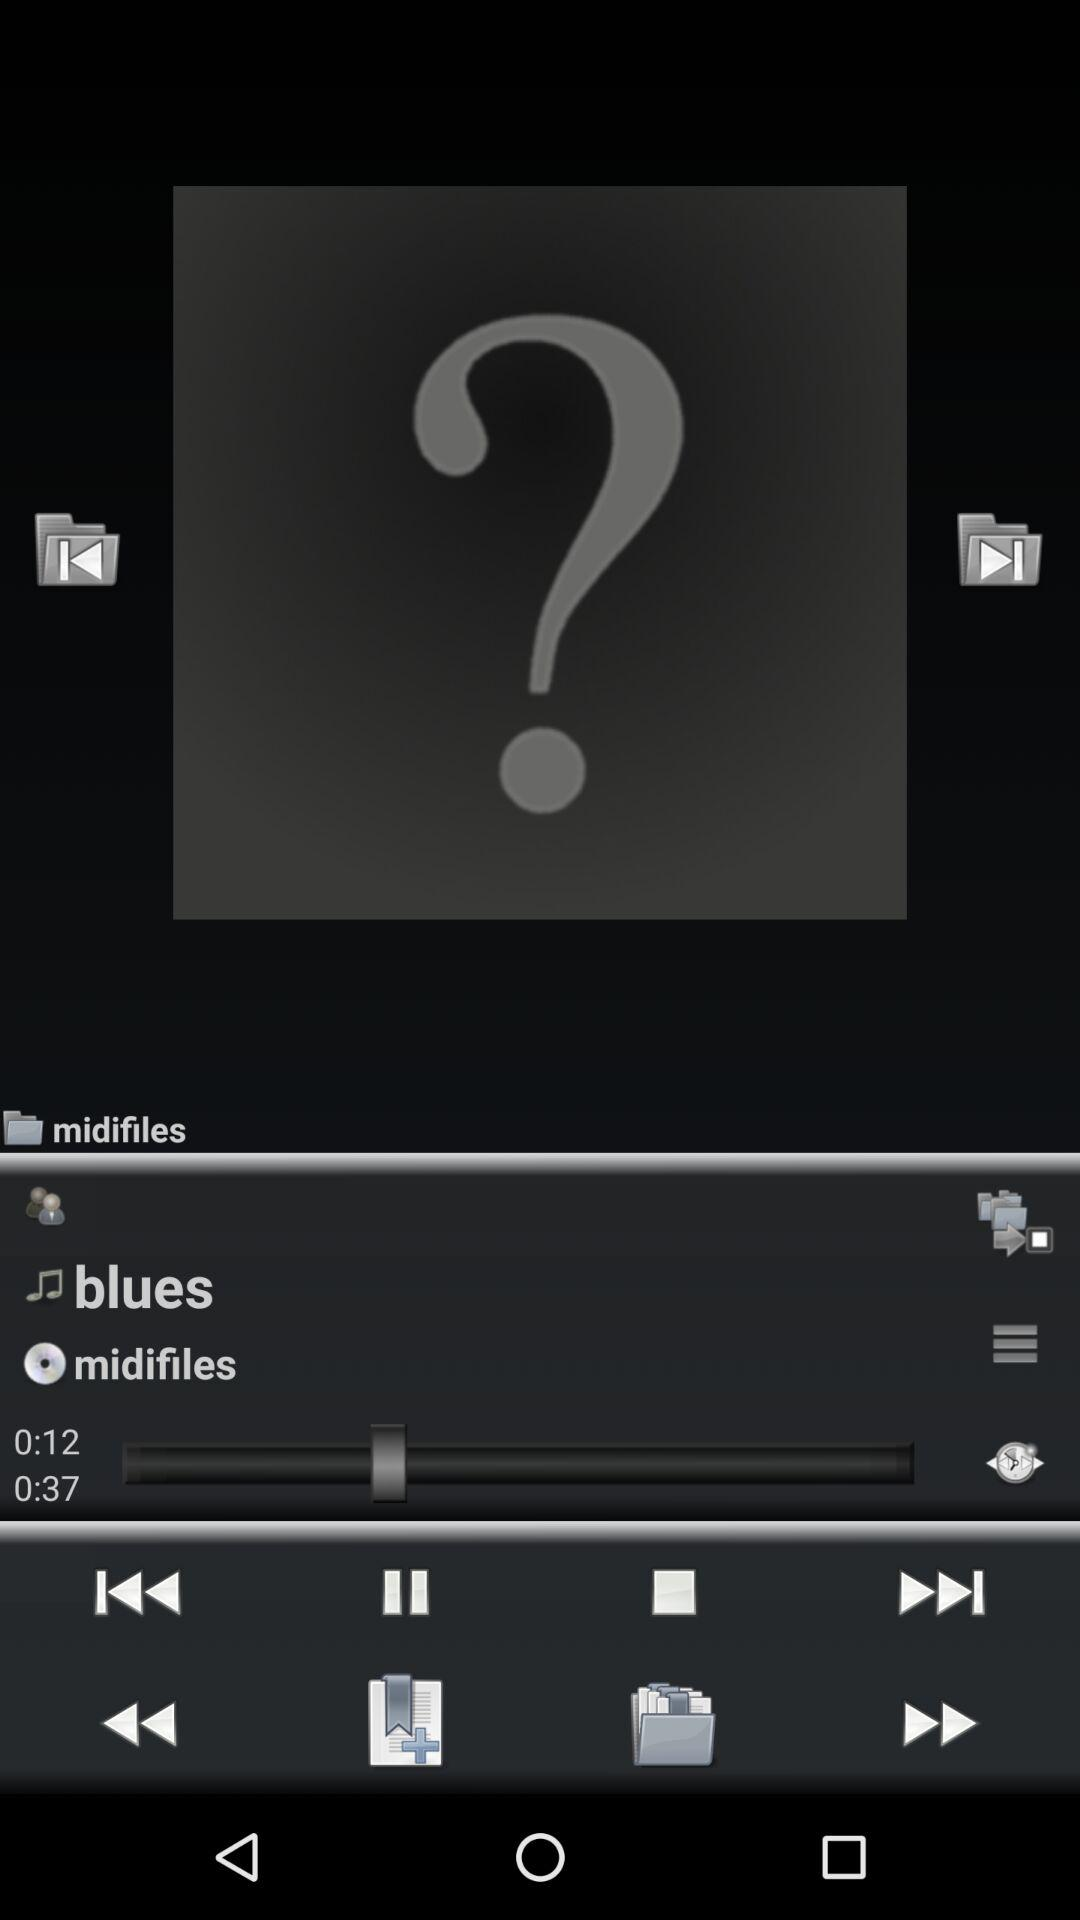How many more seconds are in the second song than the first?
Answer the question using a single word or phrase. 25 